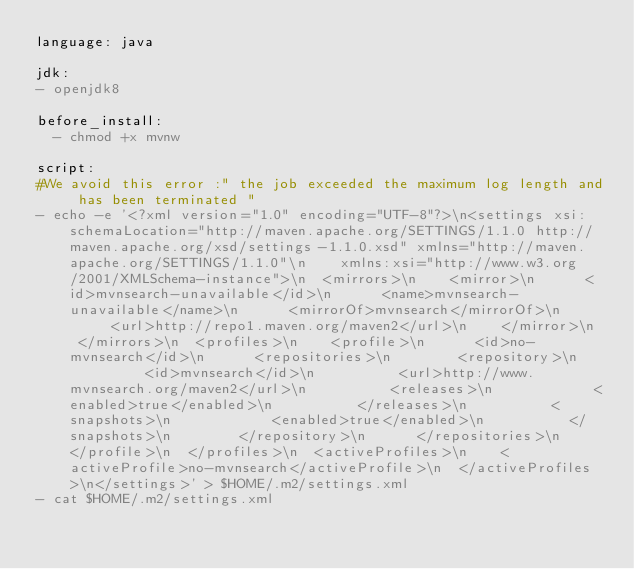<code> <loc_0><loc_0><loc_500><loc_500><_YAML_>language: java

jdk:
- openjdk8

before_install:
  - chmod +x mvnw

script:
#We avoid this error :" the job exceeded the maximum log length and has been terminated "
- echo -e '<?xml version="1.0" encoding="UTF-8"?>\n<settings xsi:schemaLocation="http://maven.apache.org/SETTINGS/1.1.0 http://maven.apache.org/xsd/settings-1.1.0.xsd" xmlns="http://maven.apache.org/SETTINGS/1.1.0"\n    xmlns:xsi="http://www.w3.org/2001/XMLSchema-instance">\n  <mirrors>\n    <mirror>\n      <id>mvnsearch-unavailable</id>\n      <name>mvnsearch-unavailable</name>\n      <mirrorOf>mvnsearch</mirrorOf>\n      <url>http://repo1.maven.org/maven2</url>\n    </mirror>\n  </mirrors>\n  <profiles>\n    <profile>\n      <id>no-mvnsearch</id>\n      <repositories>\n        <repository>\n          <id>mvnsearch</id>\n          <url>http://www.mvnsearch.org/maven2</url>\n          <releases>\n            <enabled>true</enabled>\n          </releases>\n          <snapshots>\n            <enabled>true</enabled>\n          </snapshots>\n        </repository>\n      </repositories>\n    </profile>\n  </profiles>\n  <activeProfiles>\n    <activeProfile>no-mvnsearch</activeProfile>\n  </activeProfiles>\n</settings>' > $HOME/.m2/settings.xml
- cat $HOME/.m2/settings.xml
</code> 